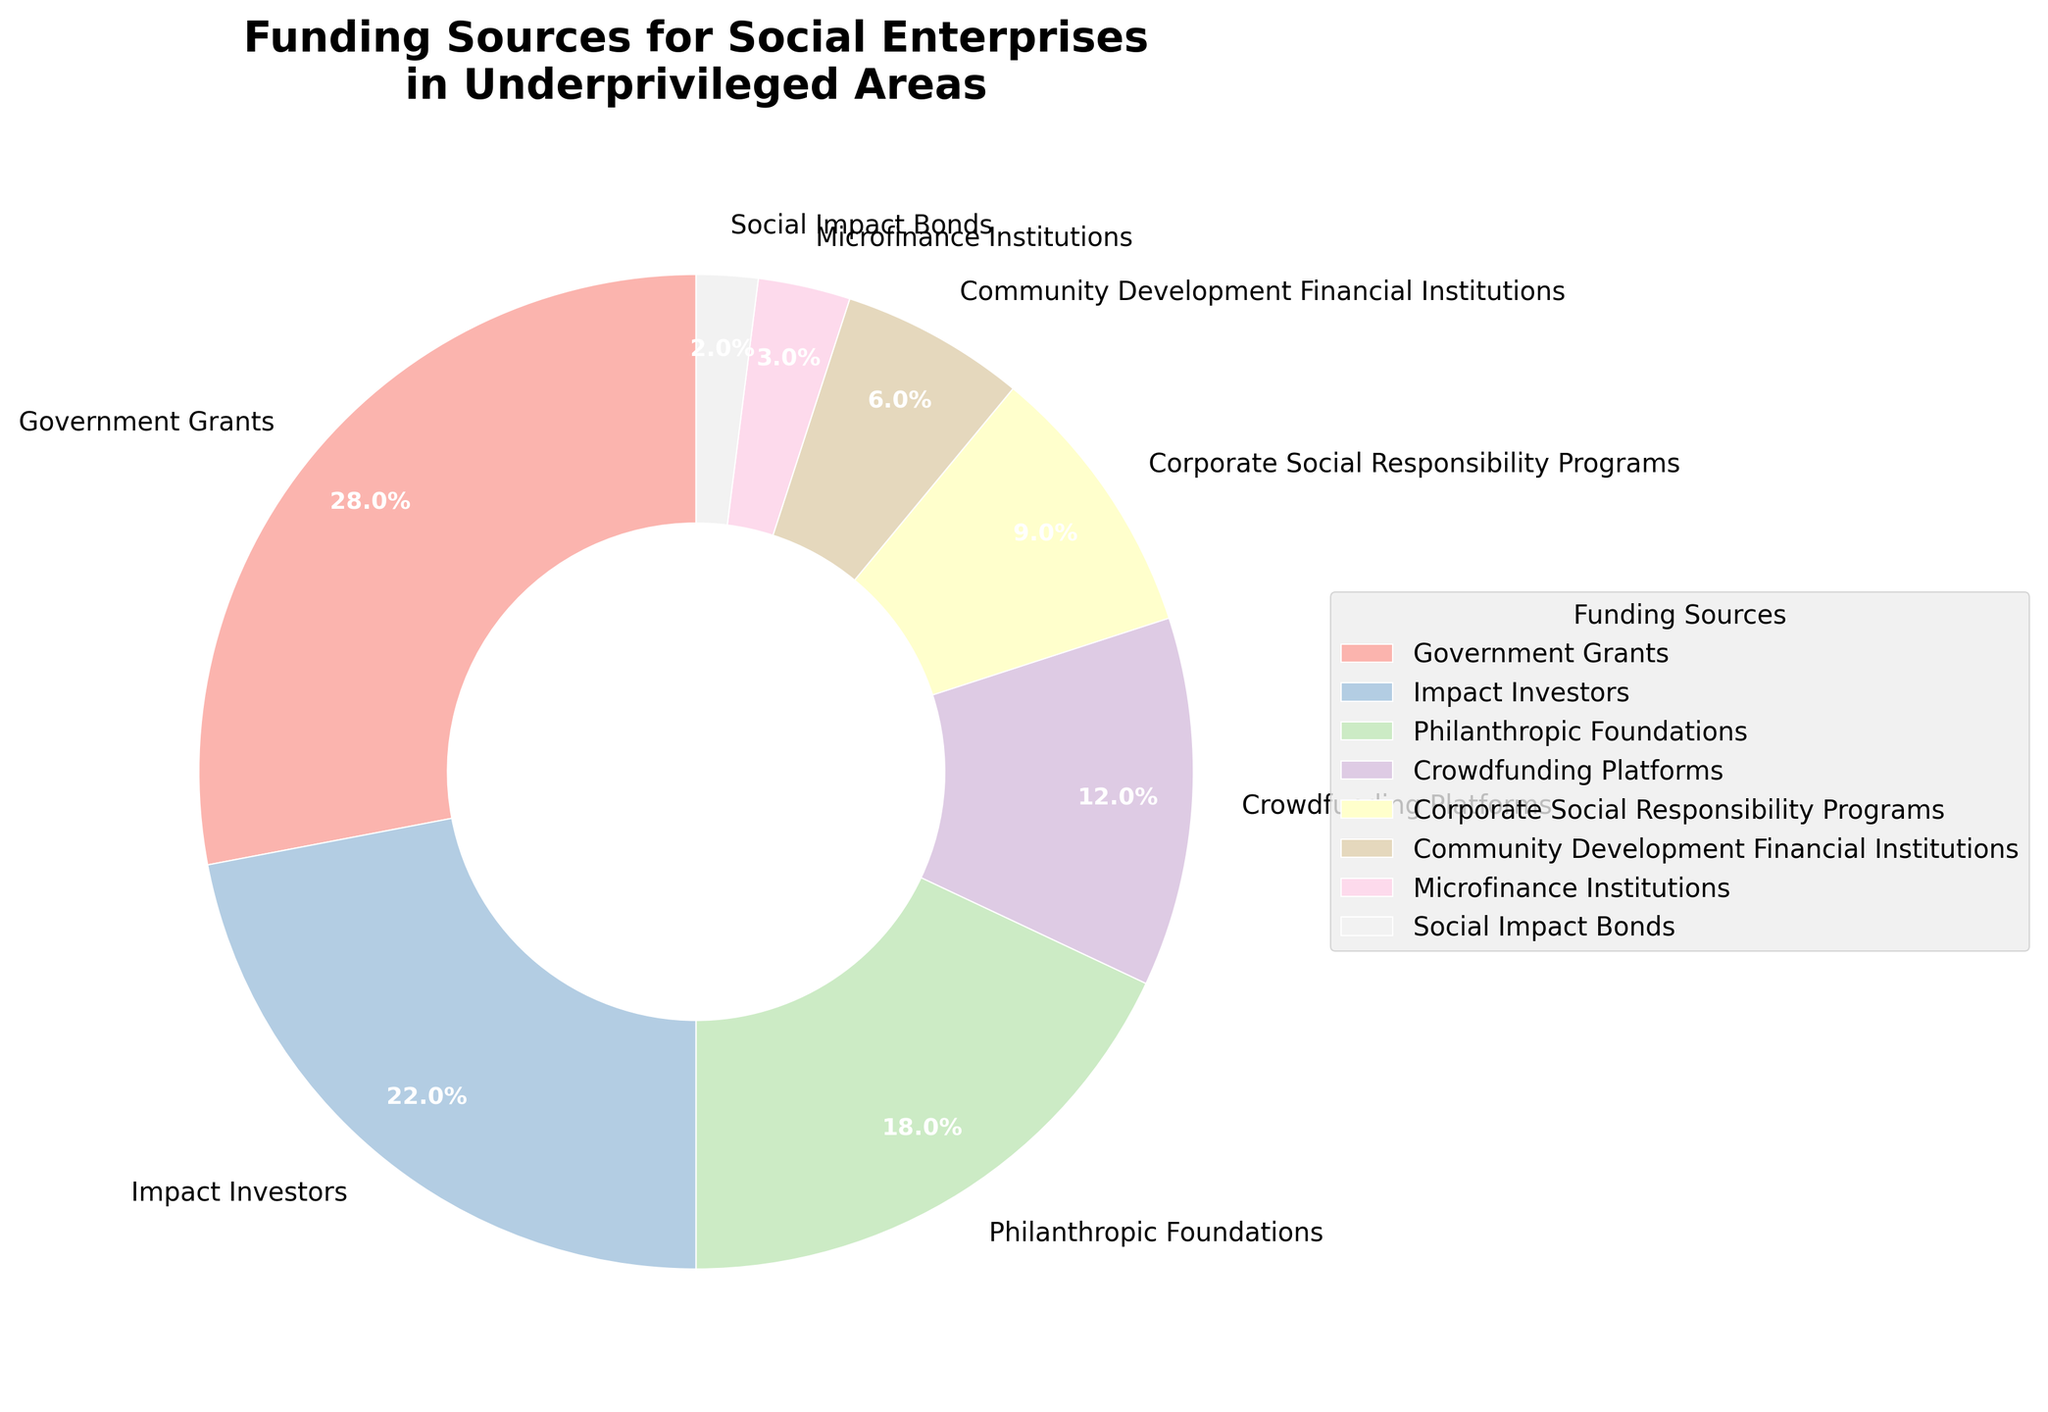Which funding source contributes the highest percentage to social enterprises in underprivileged areas? Look at the segment with the largest percentage on the pie chart. It is labeled "Government Grants" at 28%.
Answer: Government Grants Which funding source has the smallest contribution? Identify the segment with the smallest percentage. It is labeled "Social Impact Bonds" at 2%.
Answer: Social Impact Bonds How much more does Impact Investors contribute compared to Microfinance Institutions? Find the percentages for Impact Investors and Microfinance Institutions from the pie chart: 22% and 3%, respectively. Subtract the percentage of Microfinance Institutions from that of Impact Investors: 22% - 3% = 19%.
Answer: 19% What is the combined percentage contribution of Philanthropic Foundations and Corporate Social Responsibility Programs? Find the percentages for both Philanthropic Foundations and Corporate Social Responsibility Programs from the pie chart: 18% and 9%, respectively. Add these percentages: 18% + 9% = 27%.
Answer: 27% Which funding sources contribute more than 20%? Identify the segments on the pie chart that have a percentage greater than 20%. Government Grants (28%) and Impact Investors (22%) meet this criterion.
Answer: Government Grants and Impact Investors Is the contribution of Community Development Financial Institutions greater than or less than half of the contribution of Crowdfunding Platforms? Find the percentages for both Community Development Financial Institutions and Crowdfunding Platforms from the pie chart: 6% and 12%, respectively. Half of 12% is 6%. Community Development Financial Institutions contribute exactly 6%, which is equal to half of the contribution from Crowdfunding Platforms.
Answer: Equal Which two funding sources have a combined contribution equal to 30%? Look for pairs of percentages from the pie chart that sum to 30%. Impact Investors (22%) and Microfinance Institutions (3%) combined give 25% which is not 30%, then check Government Grants (28%) and Social Impact Bonds (2%), which sum to 30%.
Answer: Government Grants and Social Impact Bonds How many funding sources contribute less than 10% each? Identify the segments on the pie chart with percentages less than 10%: Corporate Social Responsibility Programs (9%), Community Development Financial Institutions (6%), Microfinance Institutions (3%), and Social Impact Bonds (2%). Count these segments: 4 funding sources.
Answer: 4 What is the percentage difference between the highest and lowest funding sources? Find the highest and lowest percentages from the pie chart: Government Grants (28%) and Social Impact Bonds (2%). Subtract the lowest percentage from the highest percentage: 28% - 2% = 26%.
Answer: 26% 